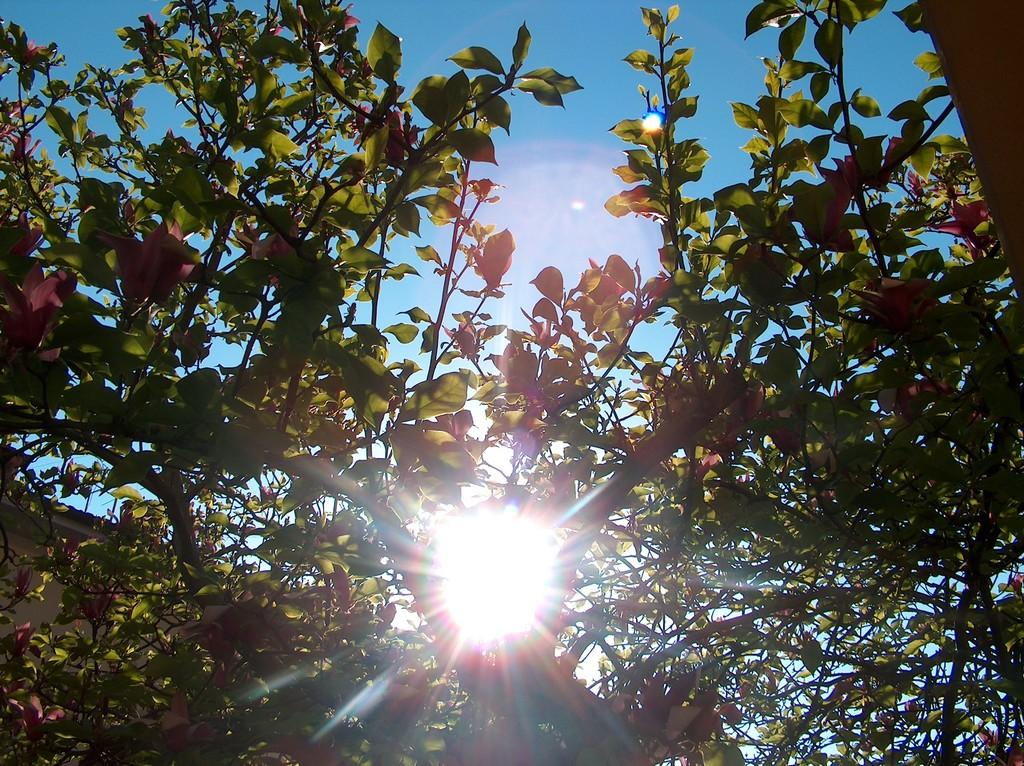What is present on the branches of the tree in the image? There is a group of leaves on the branches of a tree in the image. What can be seen in the sky in the background of the image? The sun is visible in the sky in the background of the image. Who is the owner of the shop in the image? There is no shop present in the image, so it is not possible to determine the owner. 